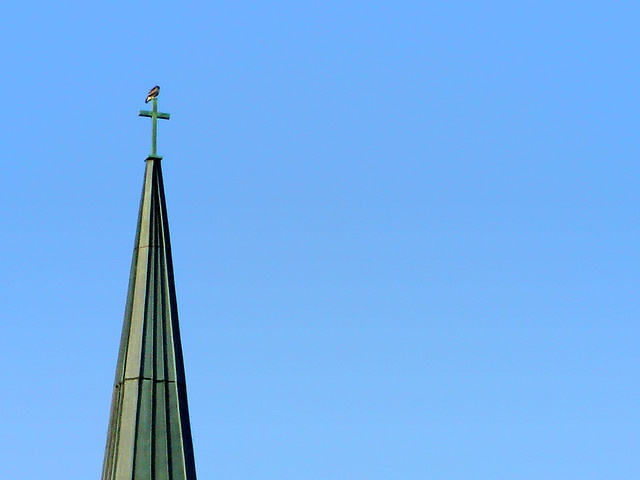Describe the objects in this image and their specific colors. I can see a bird in lightblue, black, gray, olive, and maroon tones in this image. 